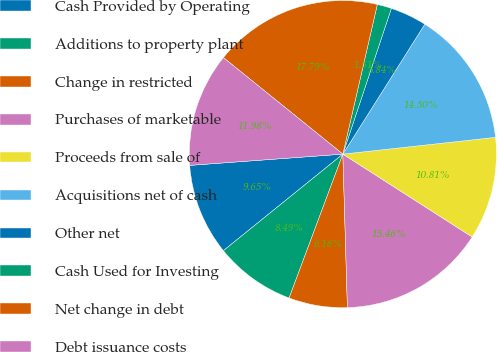<chart> <loc_0><loc_0><loc_500><loc_500><pie_chart><fcel>Cash Provided by Operating<fcel>Additions to property plant<fcel>Change in restricted<fcel>Purchases of marketable<fcel>Proceeds from sale of<fcel>Acquisitions net of cash<fcel>Other net<fcel>Cash Used for Investing<fcel>Net change in debt<fcel>Debt issuance costs<nl><fcel>9.65%<fcel>8.49%<fcel>6.16%<fcel>15.46%<fcel>10.81%<fcel>14.3%<fcel>3.84%<fcel>1.51%<fcel>17.79%<fcel>11.98%<nl></chart> 